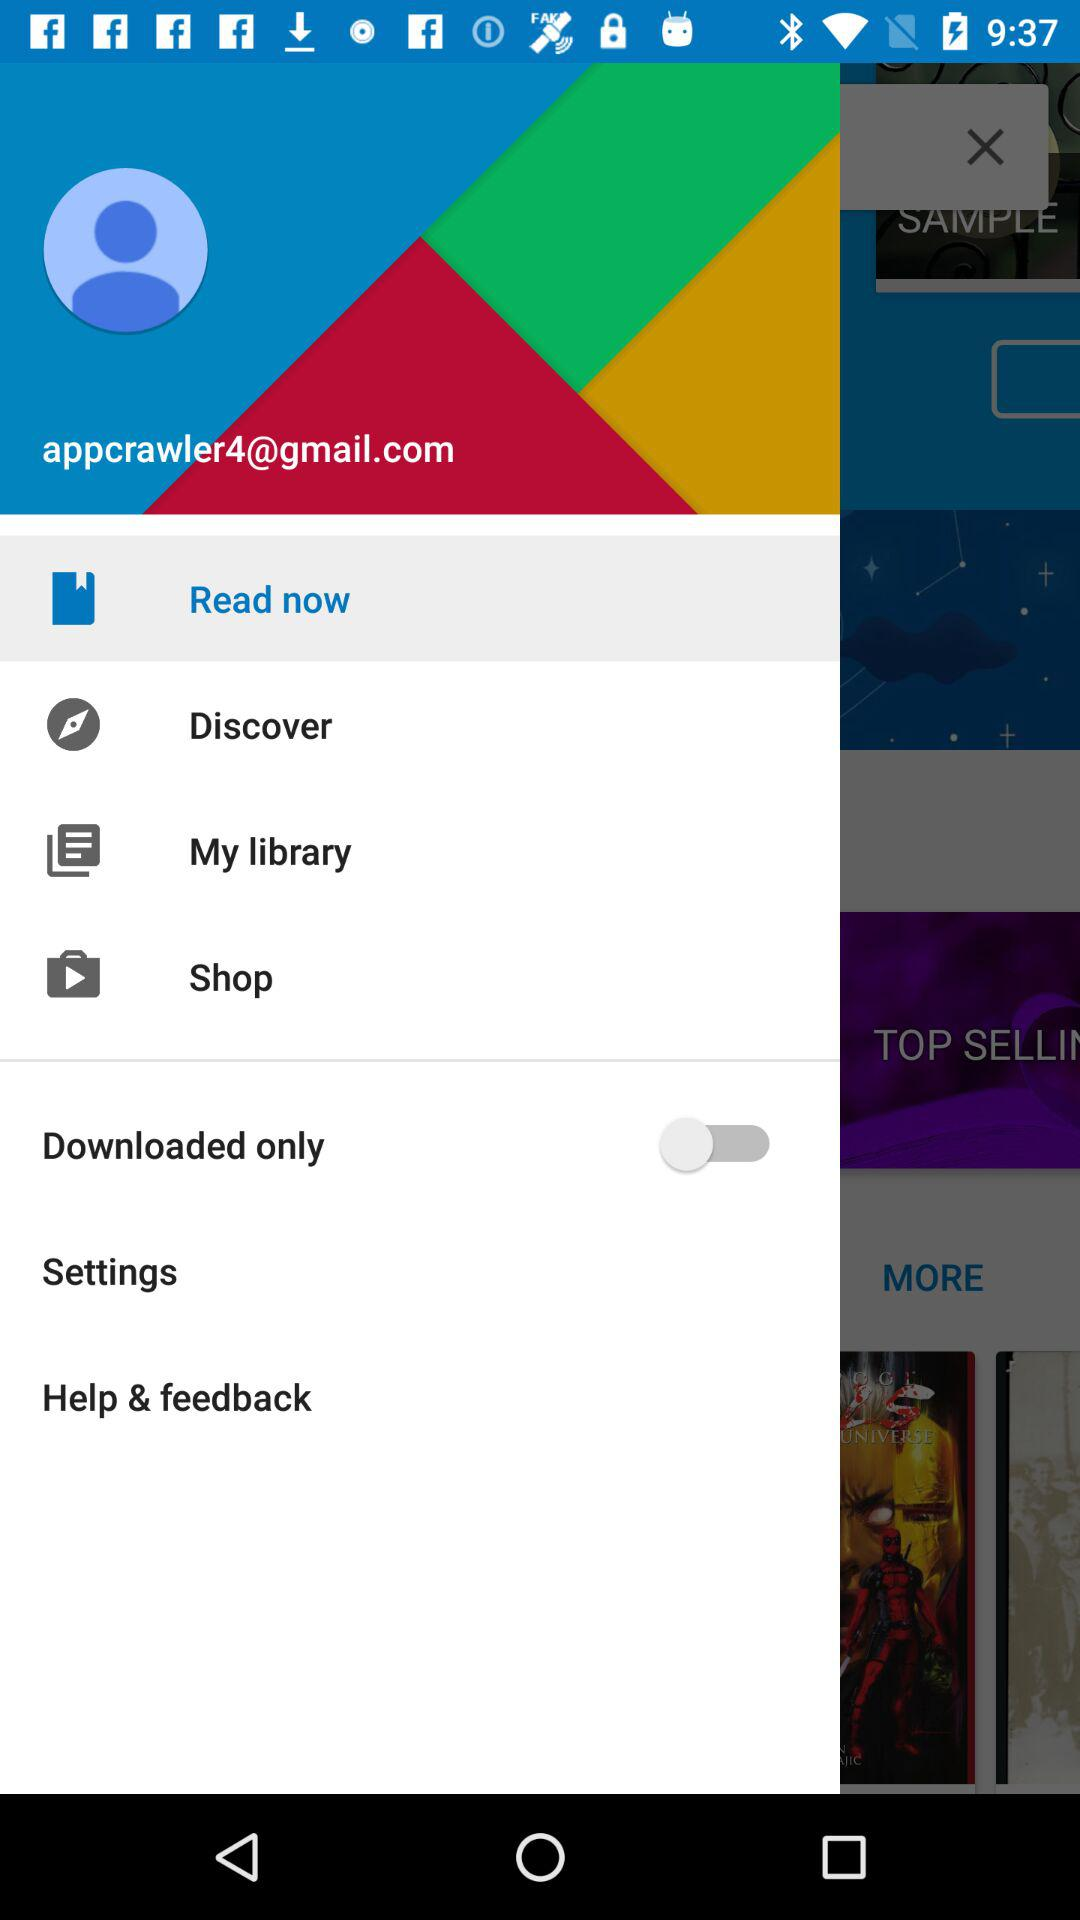Which item is selected? The selected item is "Read now". 